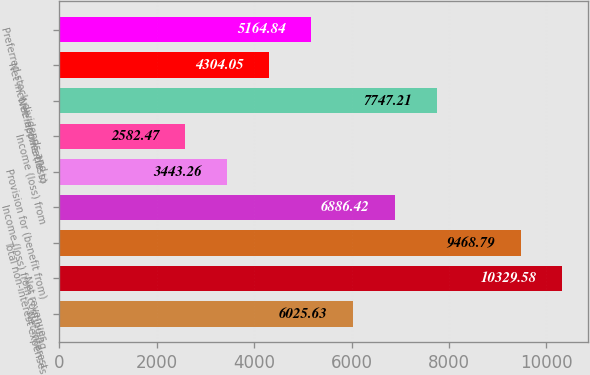Convert chart to OTSL. <chart><loc_0><loc_0><loc_500><loc_500><bar_chart><fcel>Net interest<fcel>Net revenues<fcel>Total non-interest expenses<fcel>Income (loss) from continuing<fcel>Provision for (benefit from)<fcel>Income (loss) from<fcel>Net income (loss)<fcel>Net income applicable to<fcel>Preferred stock dividends and<nl><fcel>6025.63<fcel>10329.6<fcel>9468.79<fcel>6886.42<fcel>3443.26<fcel>2582.47<fcel>7747.21<fcel>4304.05<fcel>5164.84<nl></chart> 